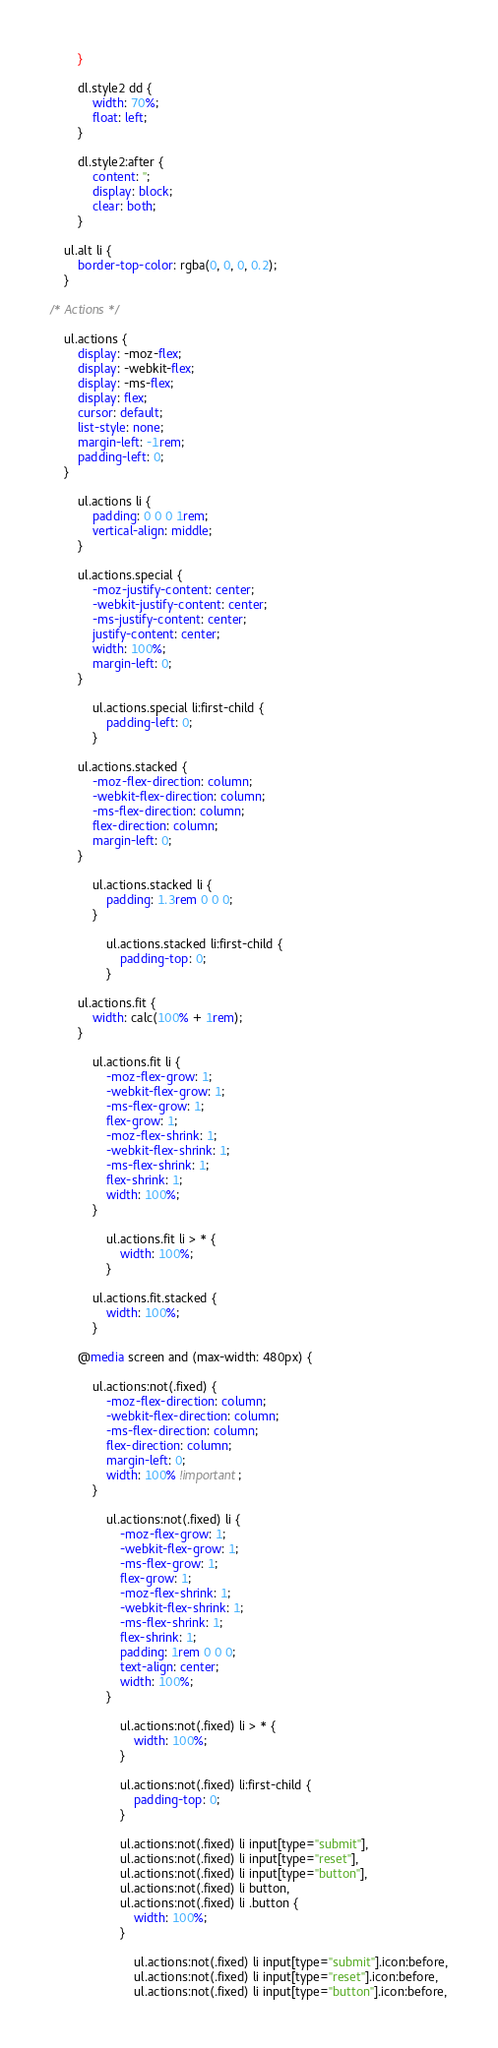<code> <loc_0><loc_0><loc_500><loc_500><_CSS_>		}

		dl.style2 dd {
			width: 70%;
			float: left;
		}

		dl.style2:after {
			content: '';
			display: block;
			clear: both;
		}

	ul.alt li {
		border-top-color: rgba(0, 0, 0, 0.2);
	}

/* Actions */

	ul.actions {
		display: -moz-flex;
		display: -webkit-flex;
		display: -ms-flex;
		display: flex;
		cursor: default;
		list-style: none;
		margin-left: -1rem;
		padding-left: 0;
	}

		ul.actions li {
			padding: 0 0 0 1rem;
			vertical-align: middle;
		}

		ul.actions.special {
			-moz-justify-content: center;
			-webkit-justify-content: center;
			-ms-justify-content: center;
			justify-content: center;
			width: 100%;
			margin-left: 0;
		}

			ul.actions.special li:first-child {
				padding-left: 0;
			}

		ul.actions.stacked {
			-moz-flex-direction: column;
			-webkit-flex-direction: column;
			-ms-flex-direction: column;
			flex-direction: column;
			margin-left: 0;
		}

			ul.actions.stacked li {
				padding: 1.3rem 0 0 0;
			}

				ul.actions.stacked li:first-child {
					padding-top: 0;
				}

		ul.actions.fit {
			width: calc(100% + 1rem);
		}

			ul.actions.fit li {
				-moz-flex-grow: 1;
				-webkit-flex-grow: 1;
				-ms-flex-grow: 1;
				flex-grow: 1;
				-moz-flex-shrink: 1;
				-webkit-flex-shrink: 1;
				-ms-flex-shrink: 1;
				flex-shrink: 1;
				width: 100%;
			}

				ul.actions.fit li > * {
					width: 100%;
				}

			ul.actions.fit.stacked {
				width: 100%;
			}

		@media screen and (max-width: 480px) {

			ul.actions:not(.fixed) {
				-moz-flex-direction: column;
				-webkit-flex-direction: column;
				-ms-flex-direction: column;
				flex-direction: column;
				margin-left: 0;
				width: 100% !important;
			}

				ul.actions:not(.fixed) li {
					-moz-flex-grow: 1;
					-webkit-flex-grow: 1;
					-ms-flex-grow: 1;
					flex-grow: 1;
					-moz-flex-shrink: 1;
					-webkit-flex-shrink: 1;
					-ms-flex-shrink: 1;
					flex-shrink: 1;
					padding: 1rem 0 0 0;
					text-align: center;
					width: 100%;
				}

					ul.actions:not(.fixed) li > * {
						width: 100%;
					}

					ul.actions:not(.fixed) li:first-child {
						padding-top: 0;
					}

					ul.actions:not(.fixed) li input[type="submit"],
					ul.actions:not(.fixed) li input[type="reset"],
					ul.actions:not(.fixed) li input[type="button"],
					ul.actions:not(.fixed) li button,
					ul.actions:not(.fixed) li .button {
						width: 100%;
					}

						ul.actions:not(.fixed) li input[type="submit"].icon:before,
						ul.actions:not(.fixed) li input[type="reset"].icon:before,
						ul.actions:not(.fixed) li input[type="button"].icon:before,</code> 